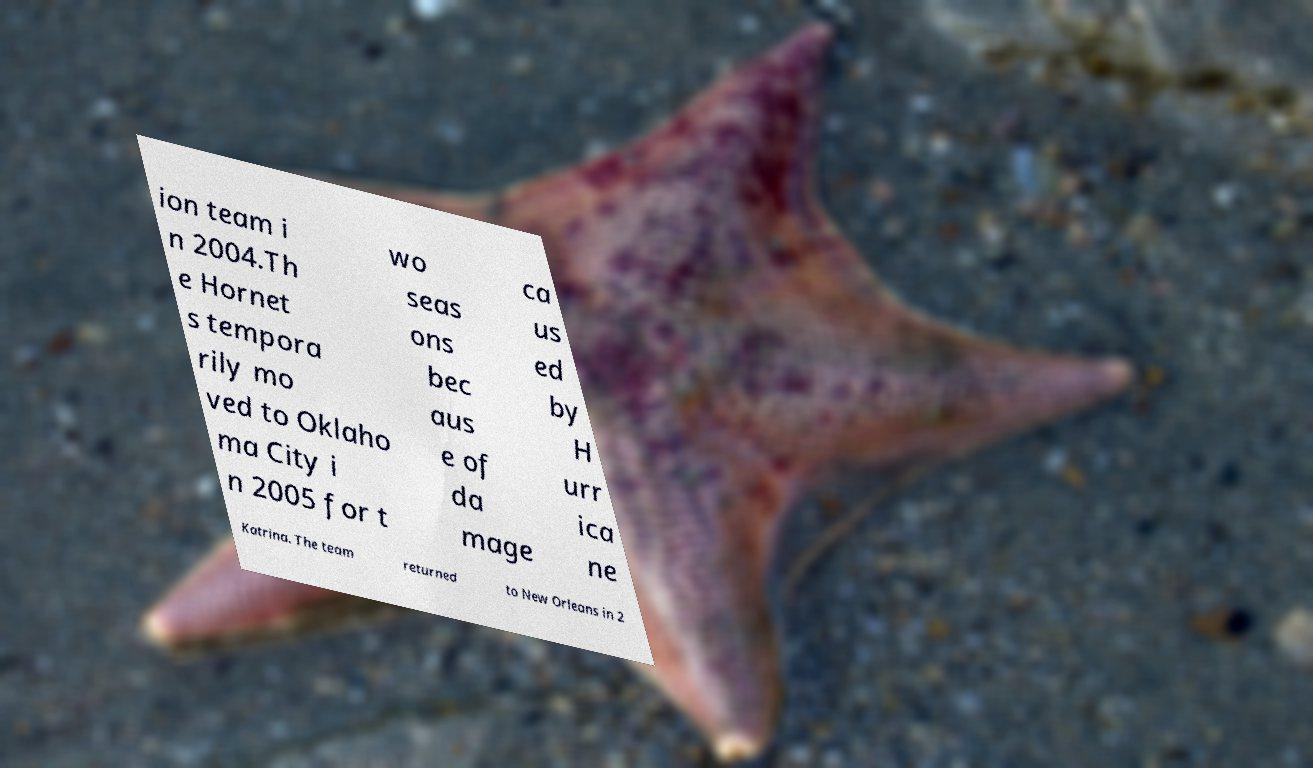Can you accurately transcribe the text from the provided image for me? ion team i n 2004.Th e Hornet s tempora rily mo ved to Oklaho ma City i n 2005 for t wo seas ons bec aus e of da mage ca us ed by H urr ica ne Katrina. The team returned to New Orleans in 2 